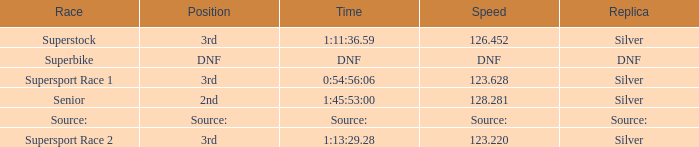Which position has a speed of 123.220? 3rd. 